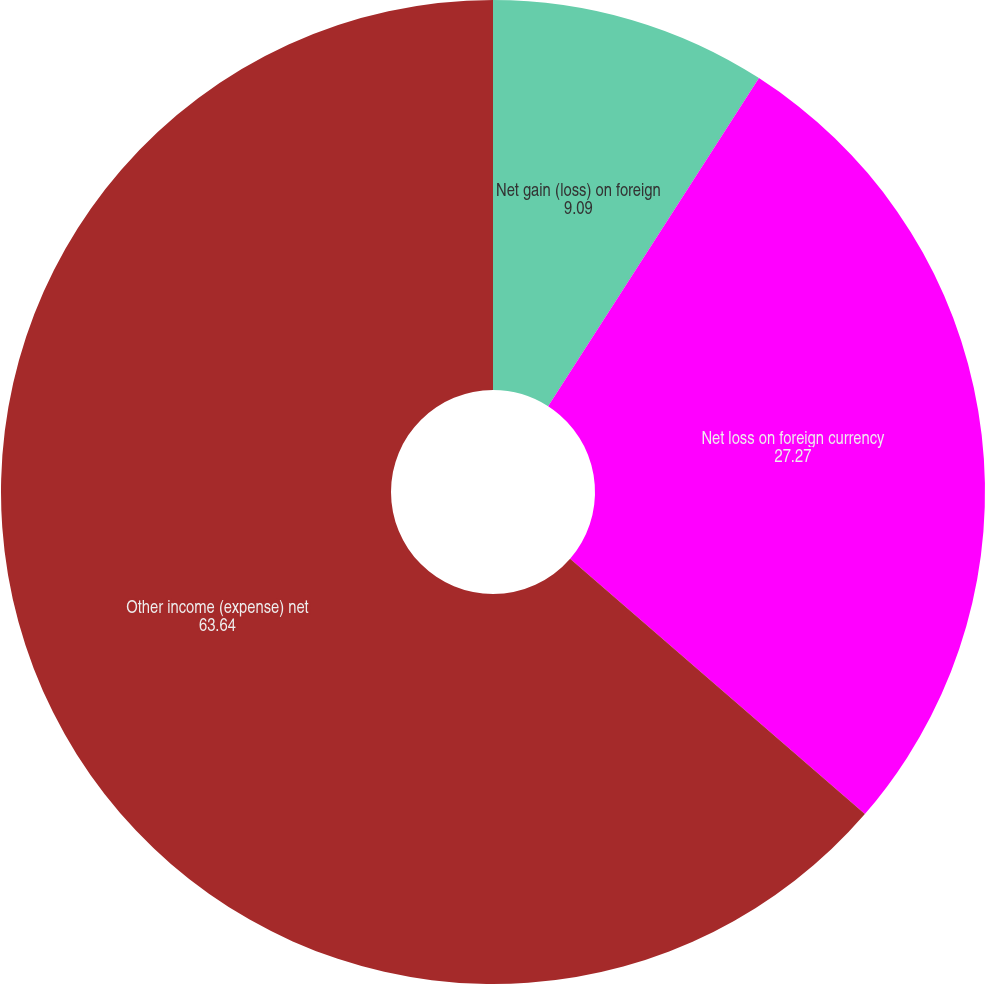Convert chart. <chart><loc_0><loc_0><loc_500><loc_500><pie_chart><fcel>Net gain (loss) on foreign<fcel>Net loss on foreign currency<fcel>Other income (expense) net<nl><fcel>9.09%<fcel>27.27%<fcel>63.64%<nl></chart> 